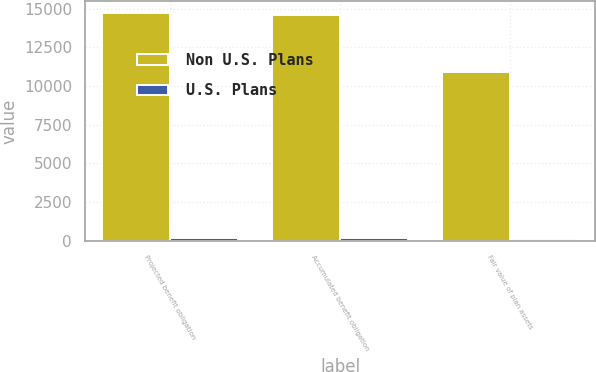Convert chart to OTSL. <chart><loc_0><loc_0><loc_500><loc_500><stacked_bar_chart><ecel><fcel>Projected benefit obligation<fcel>Accumulated benefit obligation<fcel>Fair value of plan assets<nl><fcel>Non U.S. Plans<fcel>14741<fcel>14559<fcel>10918<nl><fcel>U.S. Plans<fcel>196<fcel>176<fcel>135<nl></chart> 